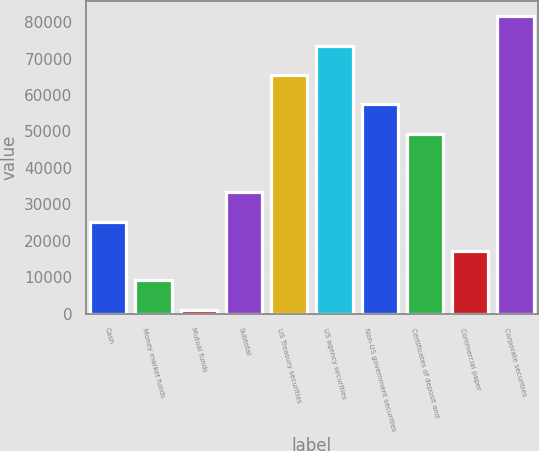Convert chart to OTSL. <chart><loc_0><loc_0><loc_500><loc_500><bar_chart><fcel>Cash<fcel>Money market funds<fcel>Mutual funds<fcel>Subtotal<fcel>US Treasury securities<fcel>US agency securities<fcel>Non-US government securities<fcel>Certificates of deposit and<fcel>Commercial paper<fcel>Corporate securities<nl><fcel>25306.1<fcel>9230.7<fcel>1193<fcel>33343.8<fcel>65494.6<fcel>73532.3<fcel>57456.9<fcel>49419.2<fcel>17268.4<fcel>81570<nl></chart> 